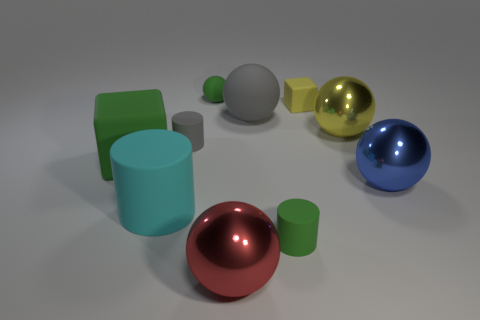What number of objects are either large gray cylinders or gray objects?
Your answer should be very brief. 2. What size is the matte cylinder that is the same color as the tiny rubber ball?
Offer a terse response. Small. Are there fewer gray rubber things than big metallic spheres?
Give a very brief answer. Yes. The green block that is the same material as the tiny green cylinder is what size?
Offer a terse response. Large. The yellow metallic sphere has what size?
Ensure brevity in your answer.  Large. The big yellow metal object is what shape?
Offer a very short reply. Sphere. Do the small rubber cylinder on the left side of the big gray sphere and the large matte ball have the same color?
Provide a succinct answer. Yes. There is a gray object that is the same shape as the large yellow metallic object; what size is it?
Provide a succinct answer. Large. There is a big metallic object that is to the left of the big metal thing that is behind the big blue shiny ball; is there a tiny rubber object that is left of it?
Give a very brief answer. Yes. What is the material of the object that is to the right of the large yellow thing?
Ensure brevity in your answer.  Metal. 